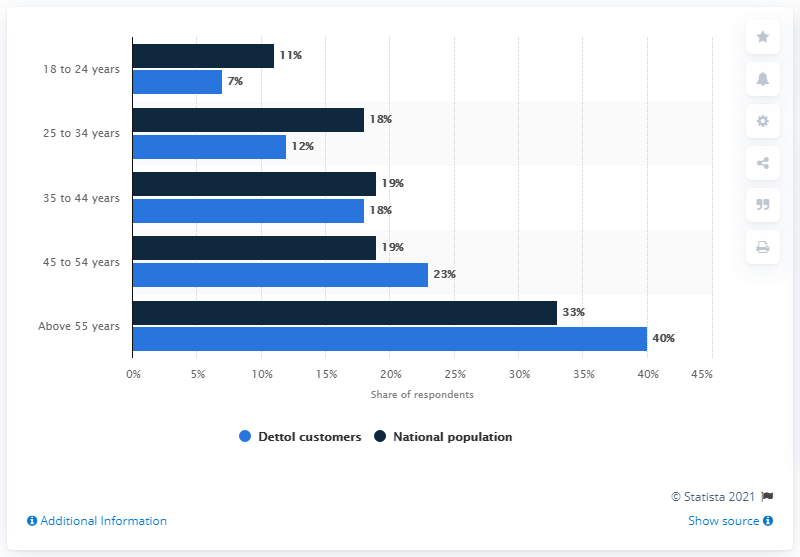Give some essential details in this illustration. The difference in Dettol customers and the national population in the 25-34 year age group is 6%. The age category with the highest breakdown is above 55 years old. 